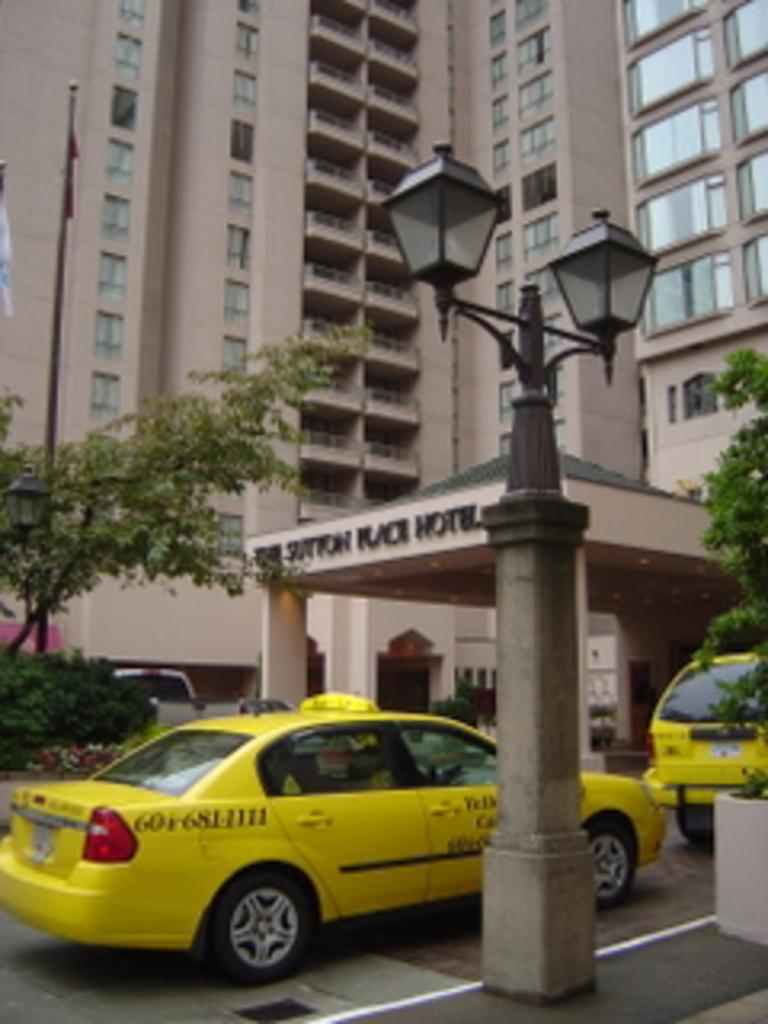<image>
Create a compact narrative representing the image presented. A yellow taxi cab is driving under the threshold for a hotel. 